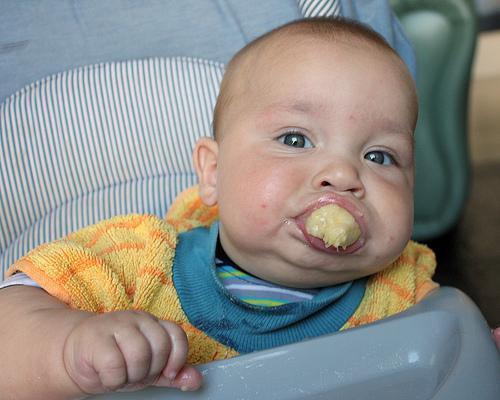How many babies are drinking water?
Give a very brief answer. 0. 